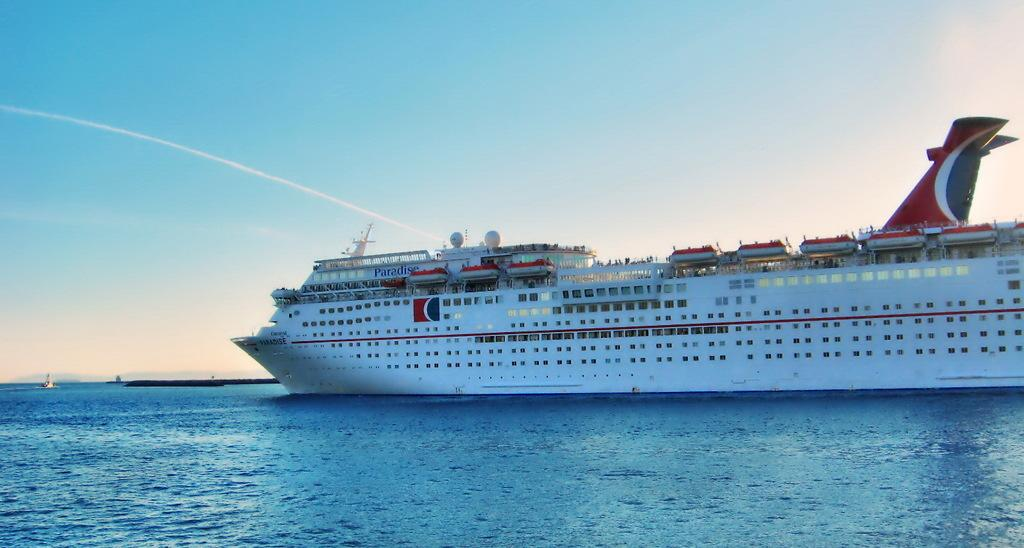What is at the bottom of the image? There is water at the bottom of the image. What can be seen in the water? There is a big ship in the image. What is the color of the ship? The ship is white in color. What is visible at the top of the image? The sky is visible at the top of the image. What is the color of the sky? The sky is blue in color. Where is the zoo located in the image? There is no zoo present in the image. What type of agreement is being made between the ship and the sky? There is no agreement being made between the ship and the sky in the image. 